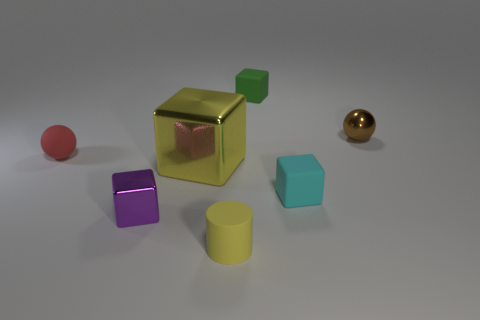Is the number of tiny green objects that are on the right side of the small green block less than the number of large shiny objects that are behind the yellow metallic block?
Offer a very short reply. No. How many other objects are there of the same shape as the red object?
Give a very brief answer. 1. Is the number of cylinders to the right of the tiny cyan matte thing less than the number of small shiny things?
Offer a terse response. Yes. What is the material of the tiny block that is behind the red ball?
Provide a succinct answer. Rubber. How many other things are the same size as the yellow shiny object?
Your answer should be very brief. 0. Are there fewer small blue rubber balls than green things?
Provide a succinct answer. Yes. What is the shape of the tiny yellow thing?
Offer a terse response. Cylinder. There is a tiny matte block that is in front of the tiny green matte thing; is it the same color as the shiny ball?
Offer a terse response. No. What is the shape of the object that is behind the cyan thing and left of the yellow block?
Provide a succinct answer. Sphere. The rubber block that is behind the tiny red matte sphere is what color?
Offer a very short reply. Green. 